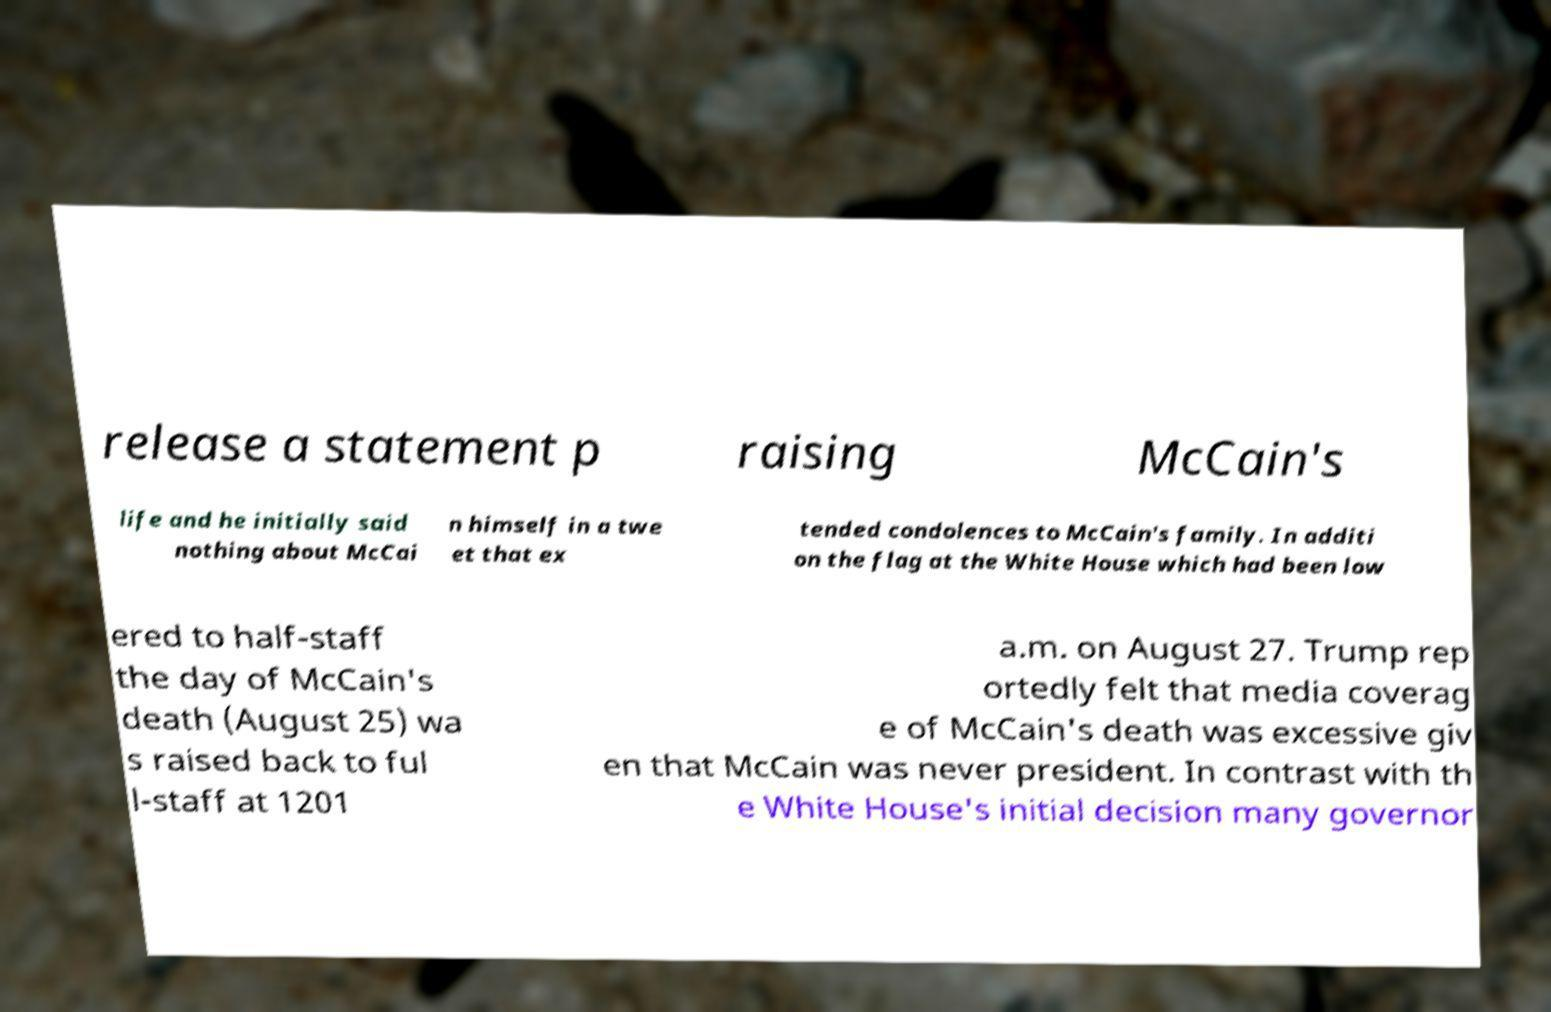For documentation purposes, I need the text within this image transcribed. Could you provide that? release a statement p raising McCain's life and he initially said nothing about McCai n himself in a twe et that ex tended condolences to McCain's family. In additi on the flag at the White House which had been low ered to half-staff the day of McCain's death (August 25) wa s raised back to ful l-staff at 1201 a.m. on August 27. Trump rep ortedly felt that media coverag e of McCain's death was excessive giv en that McCain was never president. In contrast with th e White House's initial decision many governor 